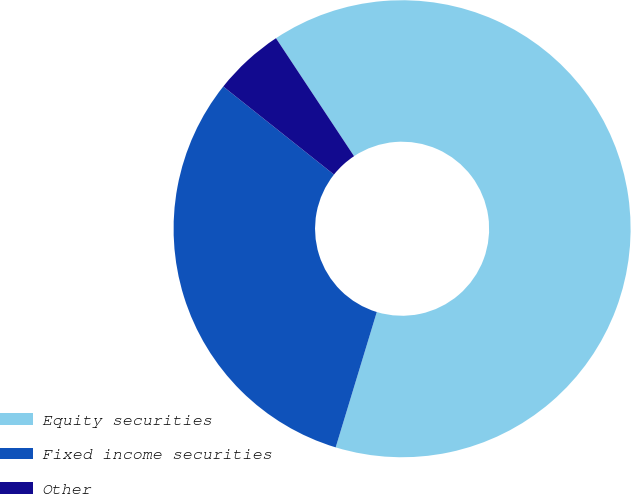Convert chart. <chart><loc_0><loc_0><loc_500><loc_500><pie_chart><fcel>Equity securities<fcel>Fixed income securities<fcel>Other<nl><fcel>64.0%<fcel>31.0%<fcel>5.0%<nl></chart> 